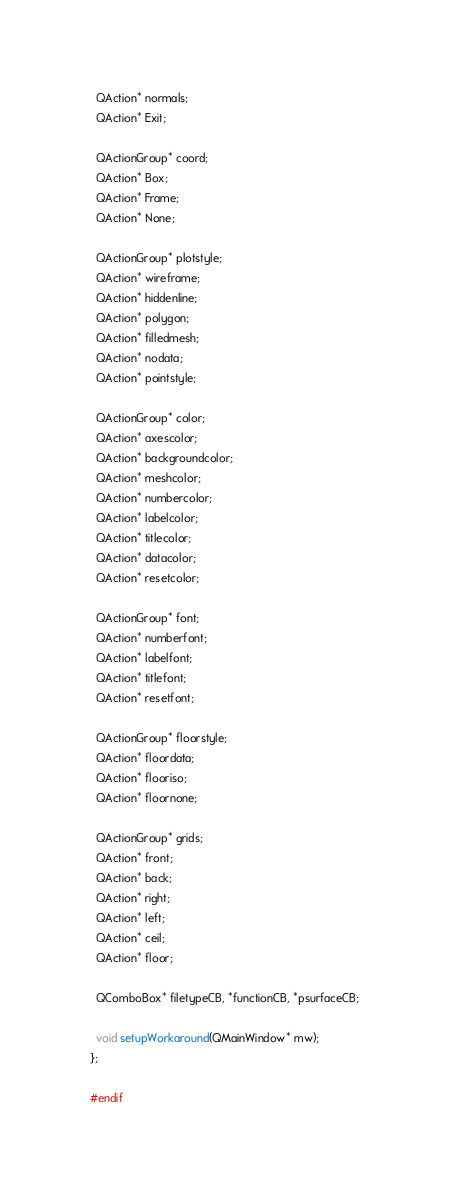Convert code to text. <code><loc_0><loc_0><loc_500><loc_500><_C_>  QAction* normals;
  QAction* Exit;
  
  QActionGroup* coord;
  QAction* Box;
  QAction* Frame;
  QAction* None;
  
  QActionGroup* plotstyle;
  QAction* wireframe;
  QAction* hiddenline;
  QAction* polygon;
  QAction* filledmesh;
  QAction* nodata;
  QAction* pointstyle;
  
  QActionGroup* color;
  QAction* axescolor;
  QAction* backgroundcolor;
  QAction* meshcolor;
  QAction* numbercolor;
  QAction* labelcolor;
  QAction* titlecolor;
  QAction* datacolor;
  QAction* resetcolor;
  
  QActionGroup* font;
  QAction* numberfont;
  QAction* labelfont;
  QAction* titlefont;
  QAction* resetfont;
  
  QActionGroup* floorstyle;
  QAction* floordata;
  QAction* flooriso;
  QAction* floornone;
  
  QActionGroup* grids;
  QAction* front;
  QAction* back;
  QAction* right;
  QAction* left;
  QAction* ceil;
  QAction* floor;

  QComboBox* filetypeCB, *functionCB, *psurfaceCB;

  void setupWorkaround(QMainWindow* mw);
};

#endif
</code> 